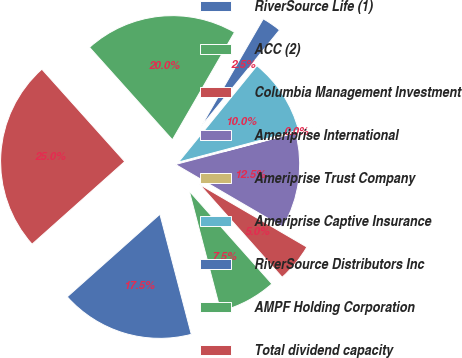<chart> <loc_0><loc_0><loc_500><loc_500><pie_chart><fcel>RiverSource Life (1)<fcel>ACC (2)<fcel>Columbia Management Investment<fcel>Ameriprise International<fcel>Ameriprise Trust Company<fcel>Ameriprise Captive Insurance<fcel>RiverSource Distributors Inc<fcel>AMPF Holding Corporation<fcel>Total dividend capacity<nl><fcel>17.48%<fcel>7.51%<fcel>5.02%<fcel>12.49%<fcel>0.04%<fcel>10.0%<fcel>2.53%<fcel>19.97%<fcel>24.95%<nl></chart> 